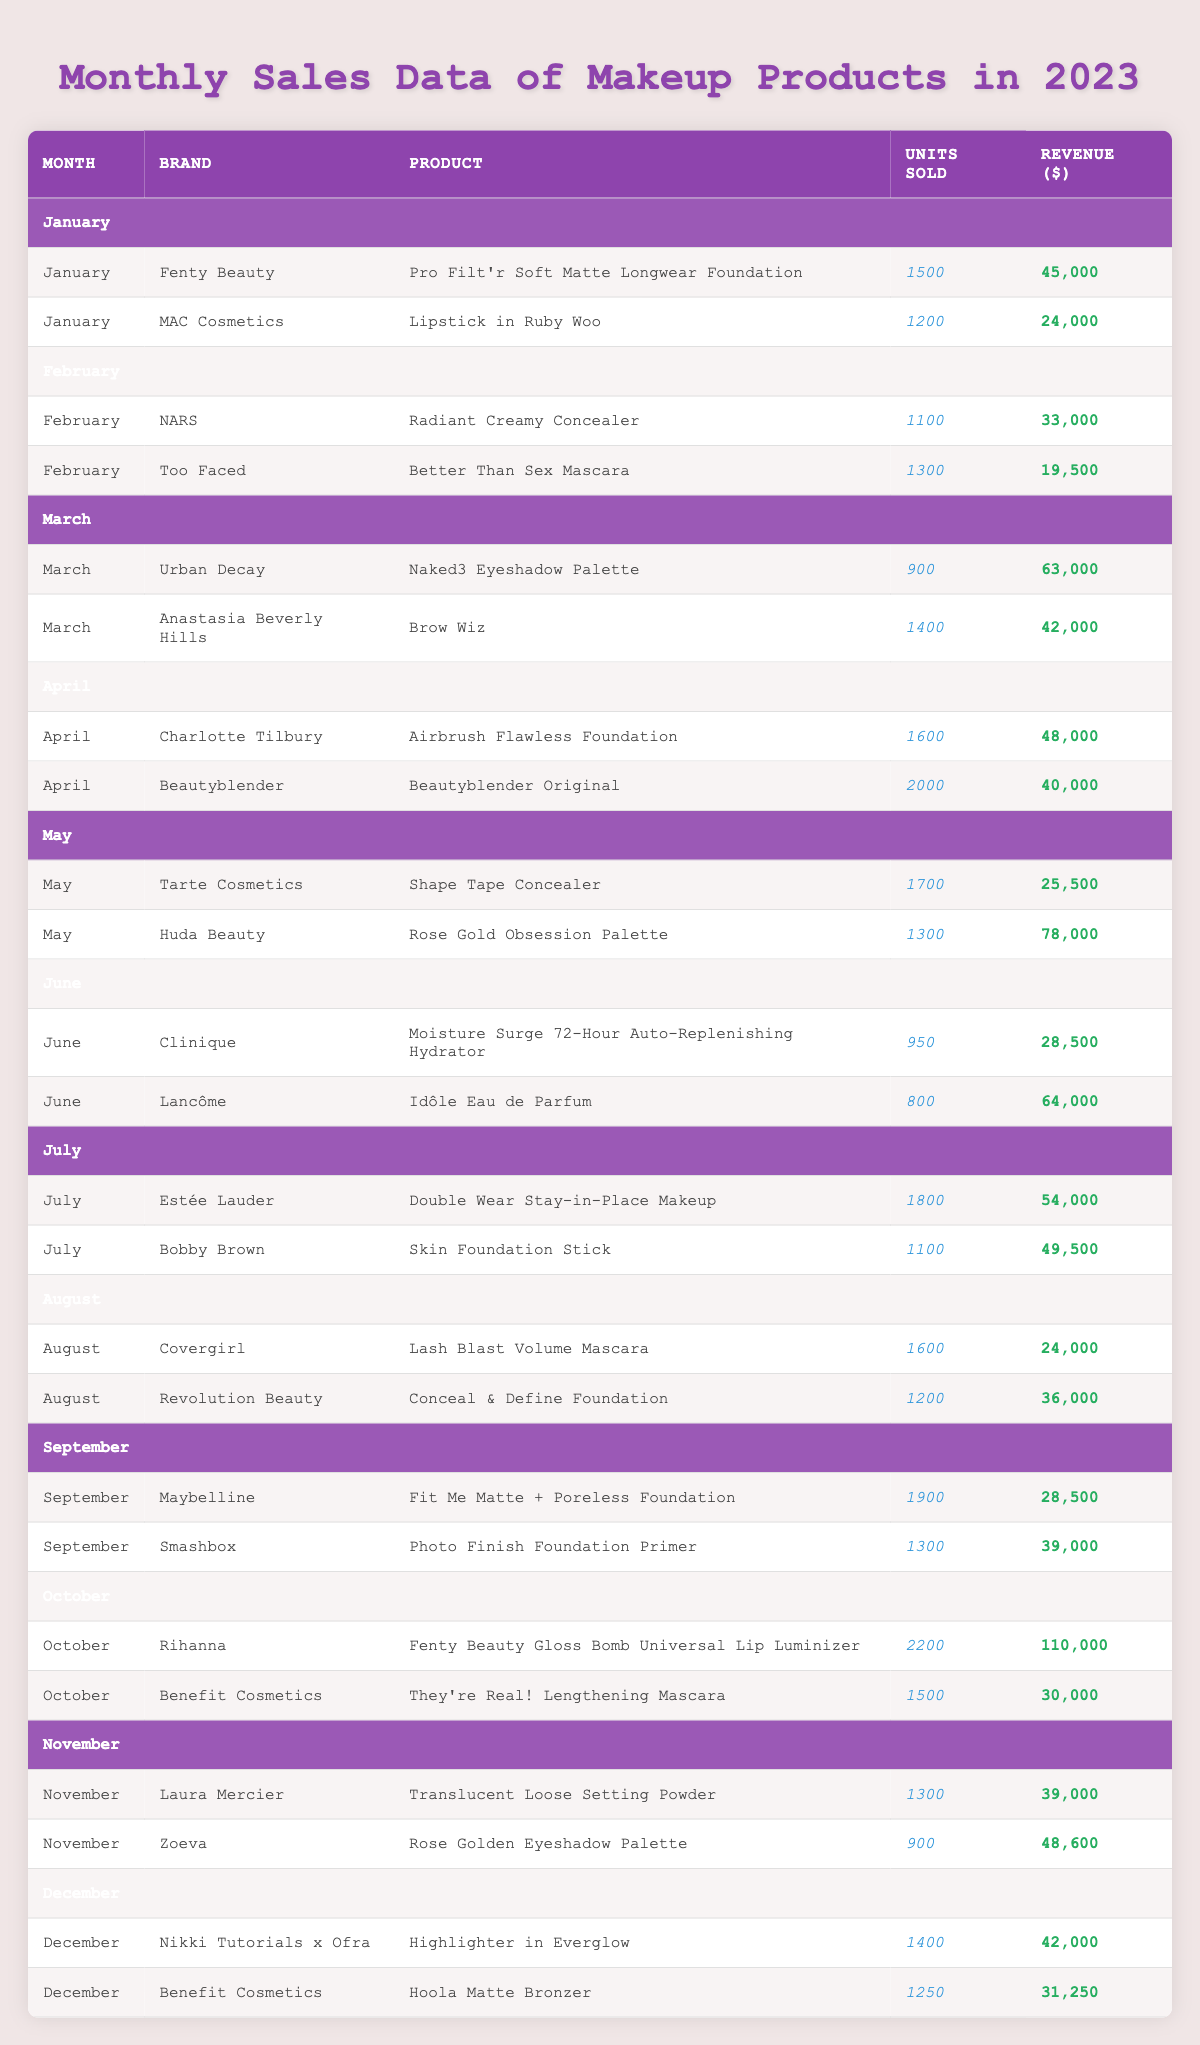What was the total revenue generated by MAC Cosmetics in January? The revenue for MAC Cosmetics in January is listed as $24,000.
Answer: $24,000 Which product had the highest units sold in October? The product with the highest units sold in October is the Fenty Beauty Gloss Bomb Universal Lip Luminizer, which sold 2,200 units.
Answer: Fenty Beauty Gloss Bomb Universal Lip Luminizer What is the average revenue of products sold in March? The total revenue in March is $63,000 (Urban Decay) + $42,000 (Anastasia Beverly Hills) = $105,000. There are 2 products; therefore, the average revenue is $105,000 / 2 = $52,500.
Answer: $52,500 Did NARS have any products sold in December? According to the table, there are no entries for NARS products in December.
Answer: No Which brand had the highest total revenue in the month of May? Huda Beauty's Rose Gold Obsession Palette generated $78,000, while Tarte Cosmetics' Shape Tape Concealer generated $25,500. The highest revenue in May is from Huda Beauty.
Answer: Huda Beauty How many total units of the Beautyblender Original were sold in April? The table shows that 2,000 units of Beautyblender Original were sold in April.
Answer: 2,000 What was the total revenue for all products sold in June? The June revenues are $28,500 (Clinique) + $64,000 (Lancôme) = $92,500.
Answer: $92,500 Which month had the highest total units sold across all brands? By summing units sold for each month, October has the highest total with 2,200 (Fenty Beauty) + 1,500 (Benefit) = 3,700 units sold.
Answer: October How much more revenue did Fenty Beauty earn compared to MAC Cosmetics in January? Fenty Beauty earned $45,000 while MAC Cosmetics earned $24,000. The difference is $45,000 - $24,000 = $21,000.
Answer: $21,000 Were more units sold in September than July? In September, 1,900 (Maybelline) + 1,300 (Smashbox) = 3,200 units sold; in July, 1,800 (Estée Lauder) + 1,100 (Bobby Brown) = 2,900 units sold. Therefore, more units were sold in September.
Answer: Yes 